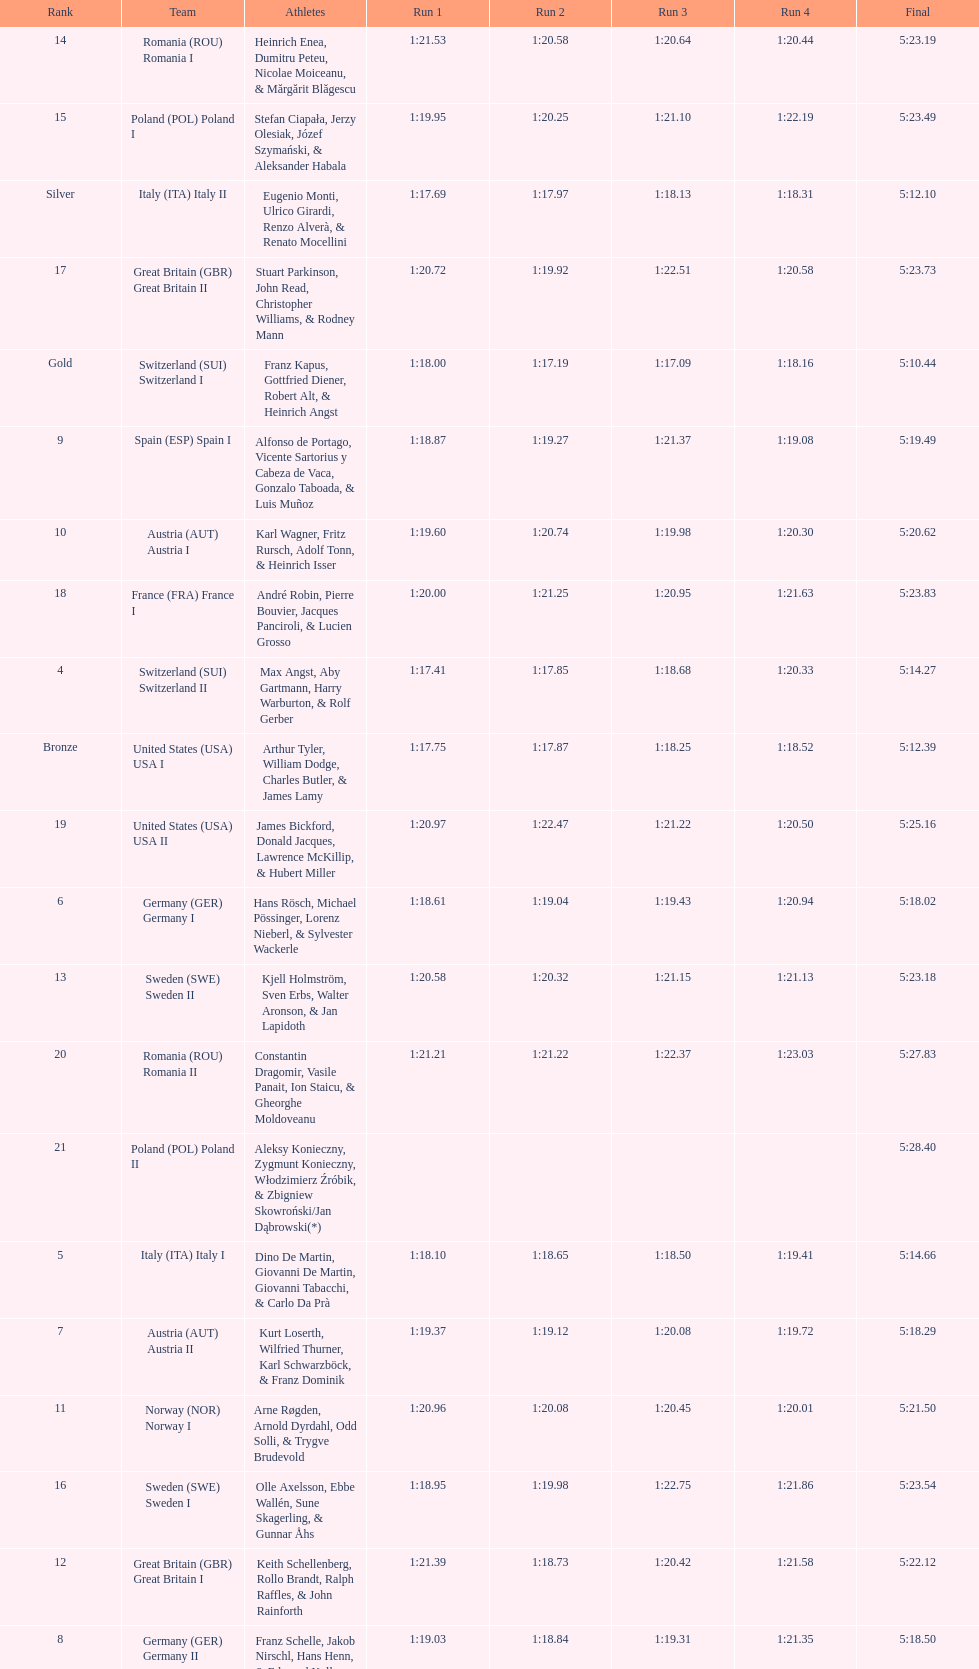Which team had the most time? Poland. 